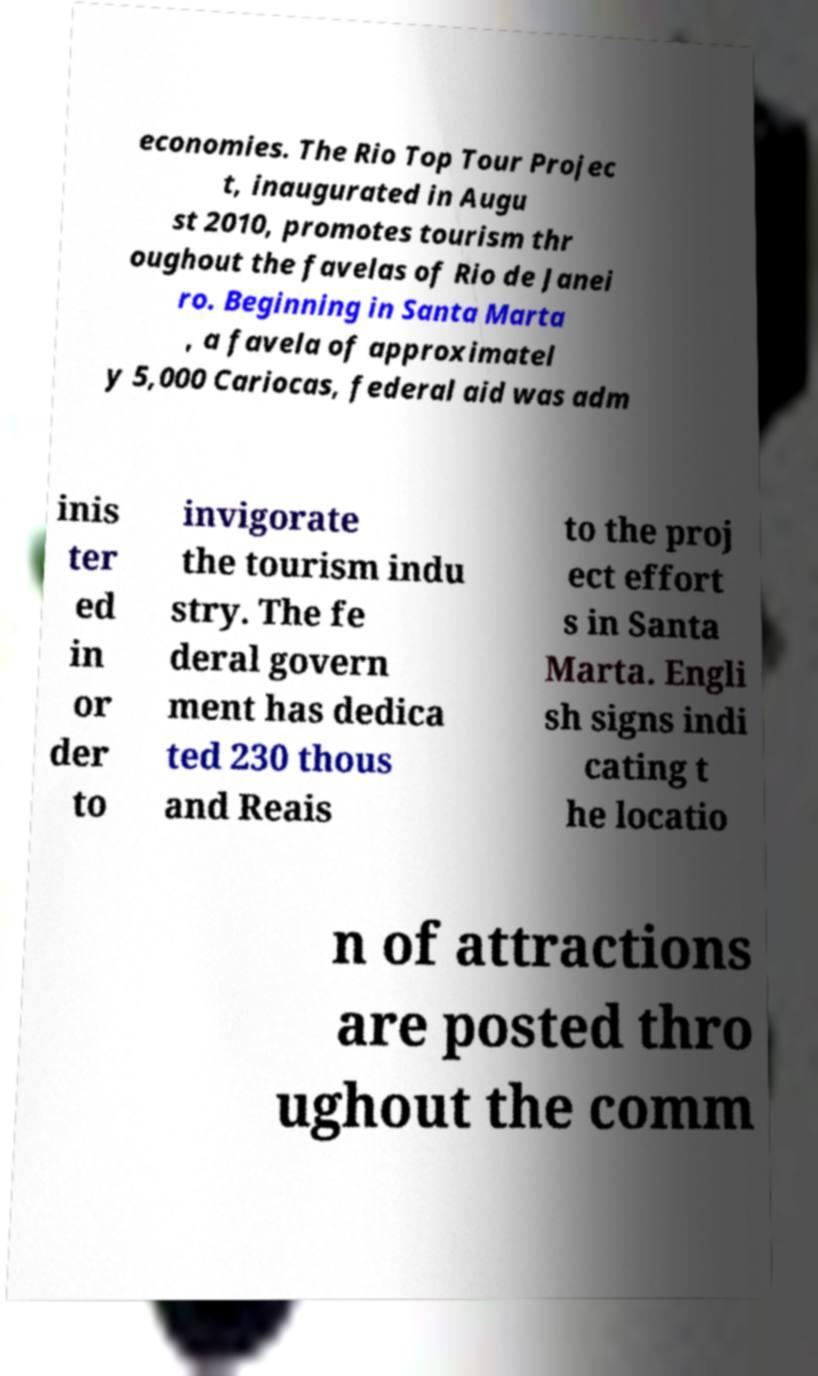What messages or text are displayed in this image? I need them in a readable, typed format. economies. The Rio Top Tour Projec t, inaugurated in Augu st 2010, promotes tourism thr oughout the favelas of Rio de Janei ro. Beginning in Santa Marta , a favela of approximatel y 5,000 Cariocas, federal aid was adm inis ter ed in or der to invigorate the tourism indu stry. The fe deral govern ment has dedica ted 230 thous and Reais to the proj ect effort s in Santa Marta. Engli sh signs indi cating t he locatio n of attractions are posted thro ughout the comm 